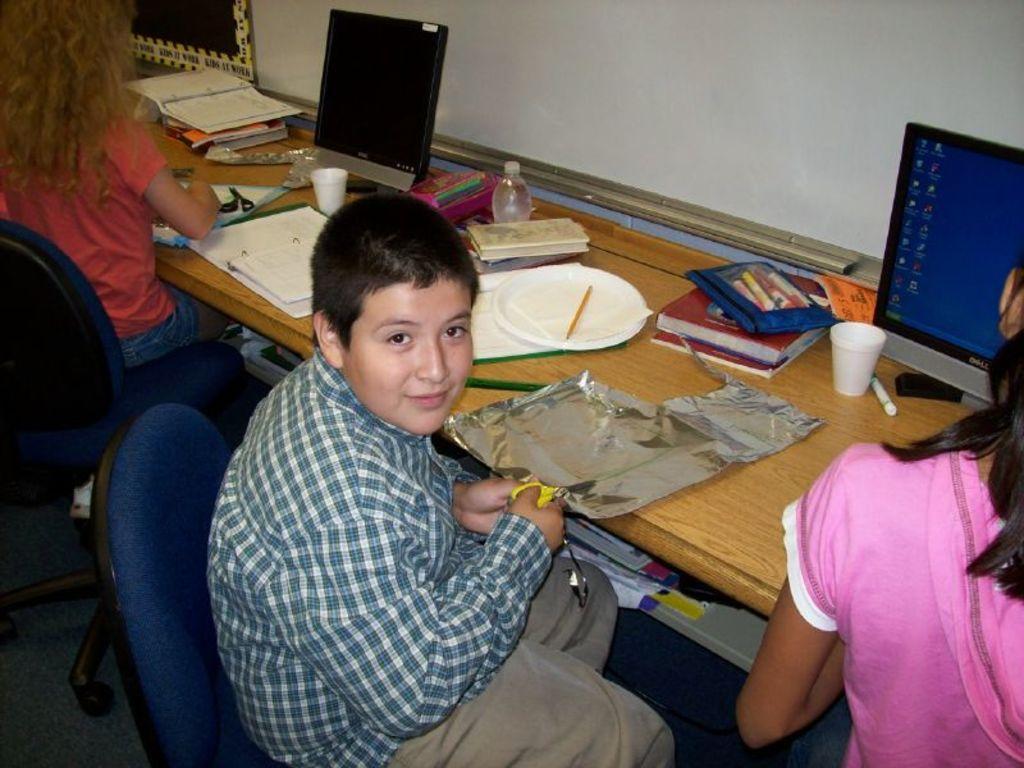In one or two sentences, can you explain what this image depicts? There are two girls and a boy sitting on the chairs at the desk. The girl at the right corner is wearing a pink dress and the girl at the left corner is wearing a orange T-shirt with blue shorts. The boy in the middle wore a shirt and a pant. He is cutting a silver paper with the help of scissors. There are two monitors on the desk. There are also paper cups, a marker, few books, a plate and many other things on the table. There are also few books and files below the table. 